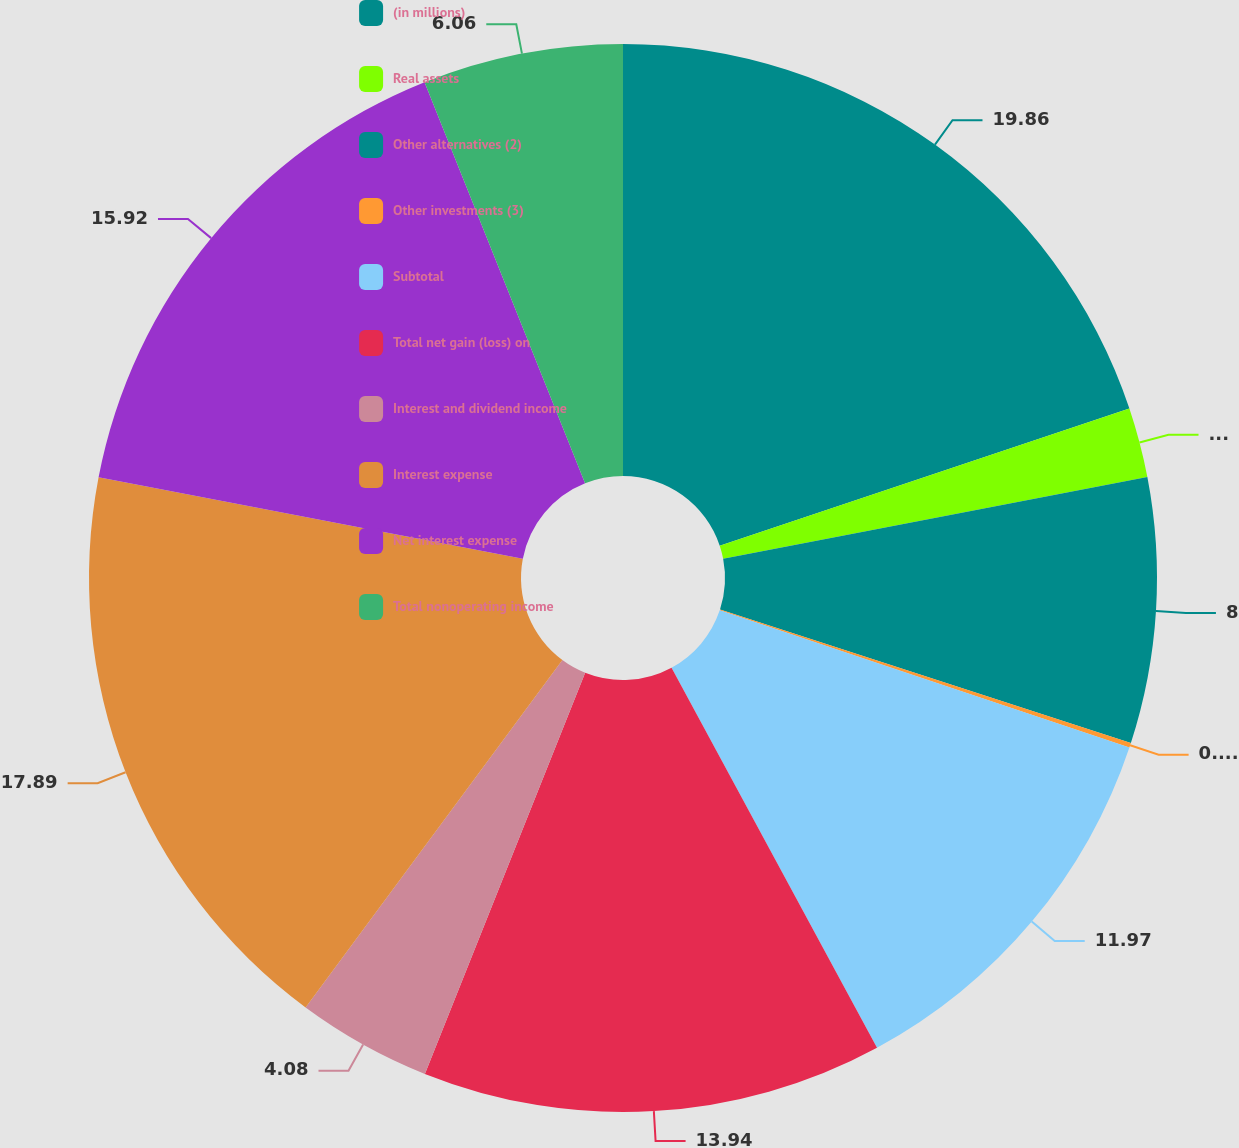<chart> <loc_0><loc_0><loc_500><loc_500><pie_chart><fcel>(in millions)<fcel>Real assets<fcel>Other alternatives (2)<fcel>Other investments (3)<fcel>Subtotal<fcel>Total net gain (loss) on<fcel>Interest and dividend income<fcel>Interest expense<fcel>Net interest expense<fcel>Total nonoperating income<nl><fcel>19.86%<fcel>2.11%<fcel>8.03%<fcel>0.14%<fcel>11.97%<fcel>13.94%<fcel>4.08%<fcel>17.89%<fcel>15.92%<fcel>6.06%<nl></chart> 